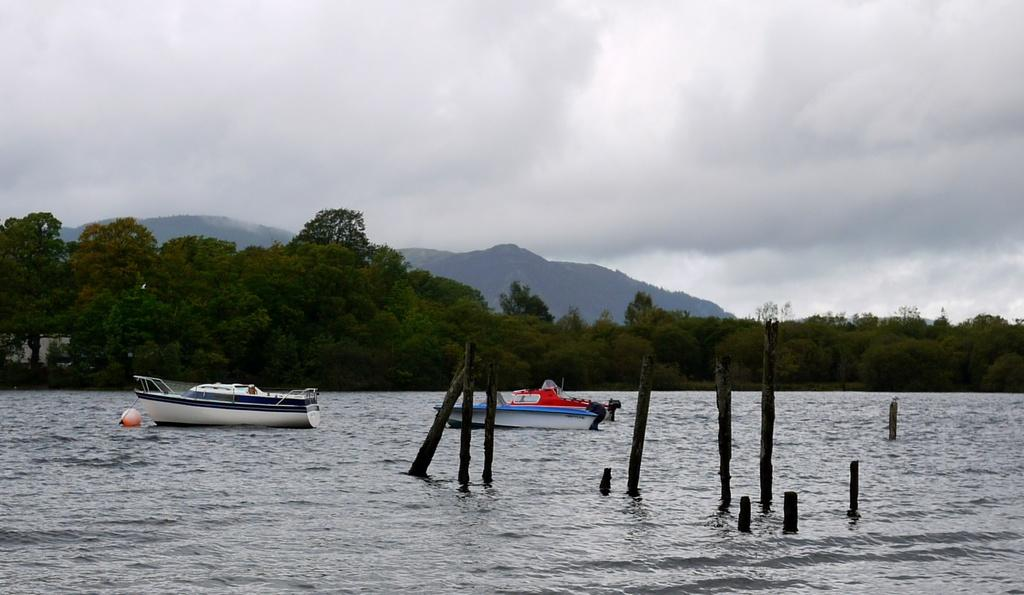What is the main element in the image? There is water in the image. What is floating on the water? There are boats on the water. What else can be seen in the water? There are wooden poles in the water. What can be seen in the background of the image? There are trees, hills, and the sky visible in the background of the image. What type of nut is being used to talk about the boats' behavior in the image? There is no nut or discussion about the boats' behavior in the image. 